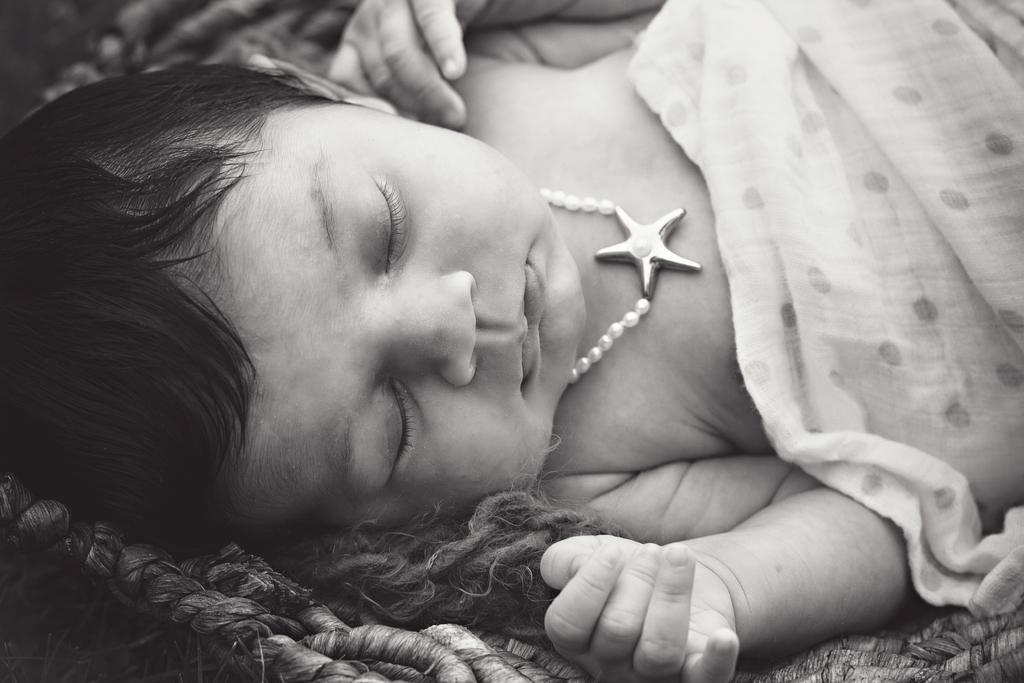Describe this image in one or two sentences. In this picture we can see a child is lying, on the right side there is a cloth, it is a black and white image. 